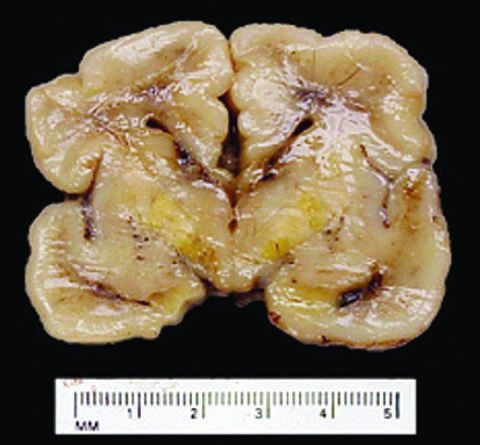what occurs because the blood-brain barrier is less developed in the neonatal period than it is in adulthood?
Answer the question using a single word or phrase. Severe hyperbilirubinemia 